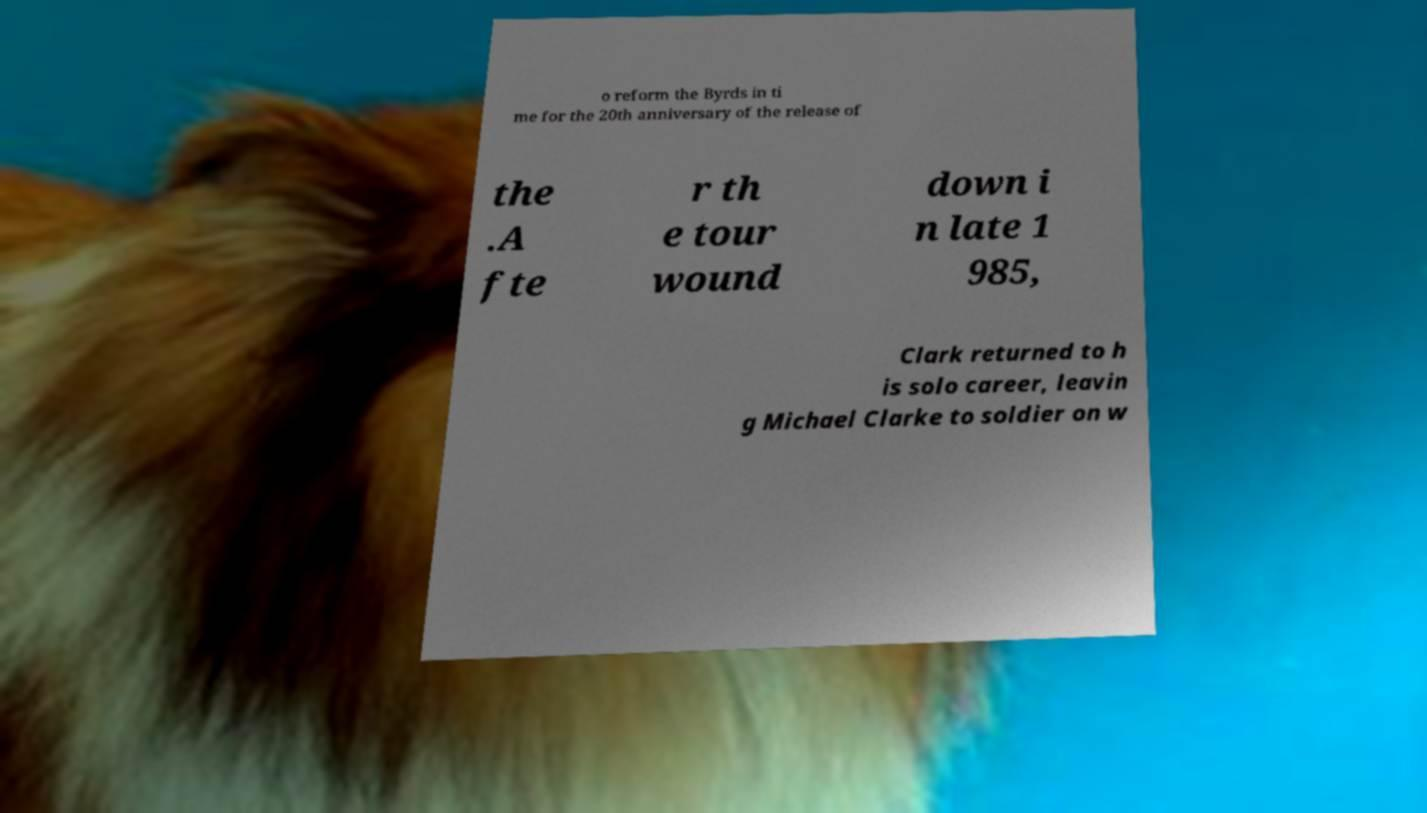What messages or text are displayed in this image? I need them in a readable, typed format. o reform the Byrds in ti me for the 20th anniversary of the release of the .A fte r th e tour wound down i n late 1 985, Clark returned to h is solo career, leavin g Michael Clarke to soldier on w 